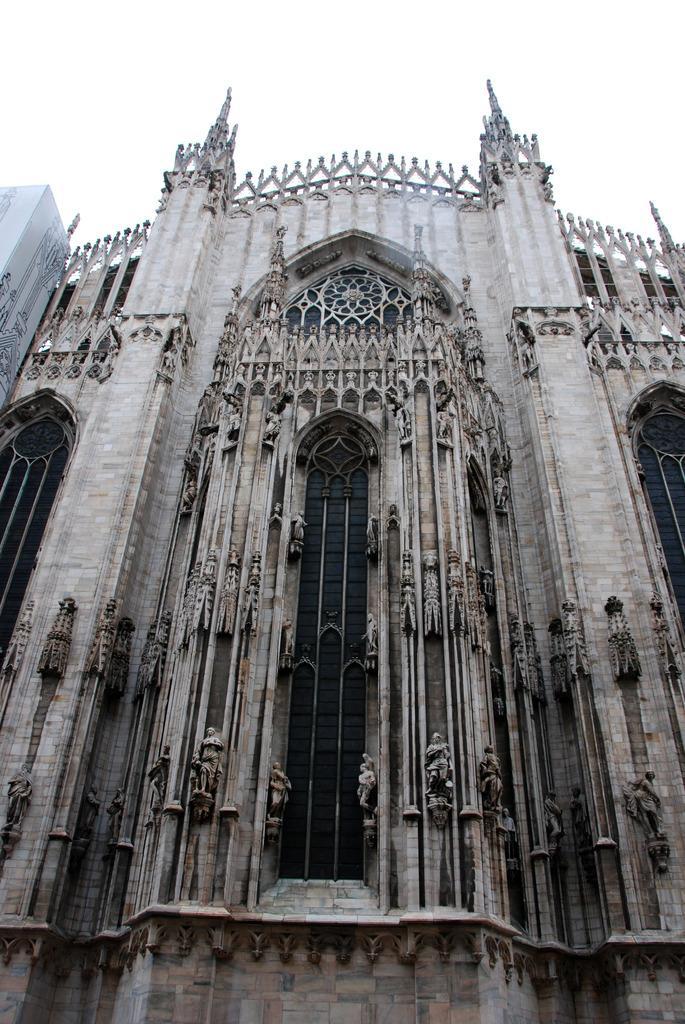In one or two sentences, can you explain what this image depicts? In this image, we can see a building with some sculptures. We can also see a white colored object on the left. We can see the sky. 